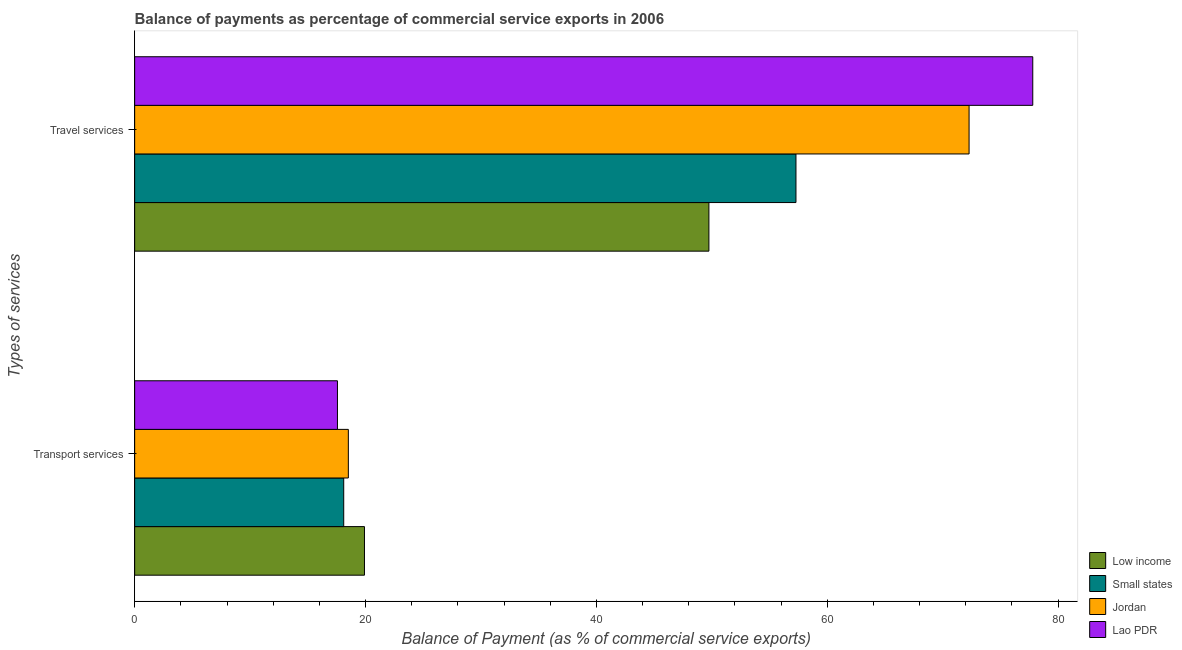How many groups of bars are there?
Give a very brief answer. 2. How many bars are there on the 1st tick from the bottom?
Offer a terse response. 4. What is the label of the 2nd group of bars from the top?
Offer a terse response. Transport services. What is the balance of payments of transport services in Lao PDR?
Keep it short and to the point. 17.57. Across all countries, what is the maximum balance of payments of travel services?
Give a very brief answer. 77.8. Across all countries, what is the minimum balance of payments of transport services?
Offer a very short reply. 17.57. In which country was the balance of payments of travel services maximum?
Ensure brevity in your answer.  Lao PDR. What is the total balance of payments of travel services in the graph?
Your response must be concise. 257.13. What is the difference between the balance of payments of travel services in Low income and that in Jordan?
Make the answer very short. -22.54. What is the difference between the balance of payments of travel services in Low income and the balance of payments of transport services in Lao PDR?
Provide a succinct answer. 32.18. What is the average balance of payments of travel services per country?
Your answer should be compact. 64.28. What is the difference between the balance of payments of travel services and balance of payments of transport services in Lao PDR?
Make the answer very short. 60.24. In how many countries, is the balance of payments of travel services greater than 24 %?
Provide a short and direct response. 4. What is the ratio of the balance of payments of transport services in Small states to that in Lao PDR?
Keep it short and to the point. 1.03. Is the balance of payments of travel services in Small states less than that in Low income?
Give a very brief answer. No. In how many countries, is the balance of payments of transport services greater than the average balance of payments of transport services taken over all countries?
Provide a succinct answer. 1. What does the 1st bar from the top in Travel services represents?
Your answer should be compact. Lao PDR. What does the 3rd bar from the bottom in Transport services represents?
Offer a very short reply. Jordan. How many countries are there in the graph?
Offer a terse response. 4. What is the difference between two consecutive major ticks on the X-axis?
Offer a terse response. 20. Does the graph contain any zero values?
Your answer should be compact. No. How many legend labels are there?
Offer a very short reply. 4. What is the title of the graph?
Make the answer very short. Balance of payments as percentage of commercial service exports in 2006. What is the label or title of the X-axis?
Your response must be concise. Balance of Payment (as % of commercial service exports). What is the label or title of the Y-axis?
Keep it short and to the point. Types of services. What is the Balance of Payment (as % of commercial service exports) in Low income in Transport services?
Provide a succinct answer. 19.91. What is the Balance of Payment (as % of commercial service exports) of Small states in Transport services?
Keep it short and to the point. 18.11. What is the Balance of Payment (as % of commercial service exports) in Jordan in Transport services?
Keep it short and to the point. 18.51. What is the Balance of Payment (as % of commercial service exports) in Lao PDR in Transport services?
Offer a terse response. 17.57. What is the Balance of Payment (as % of commercial service exports) of Low income in Travel services?
Your response must be concise. 49.75. What is the Balance of Payment (as % of commercial service exports) in Small states in Travel services?
Make the answer very short. 57.29. What is the Balance of Payment (as % of commercial service exports) of Jordan in Travel services?
Offer a terse response. 72.29. What is the Balance of Payment (as % of commercial service exports) of Lao PDR in Travel services?
Give a very brief answer. 77.8. Across all Types of services, what is the maximum Balance of Payment (as % of commercial service exports) in Low income?
Provide a succinct answer. 49.75. Across all Types of services, what is the maximum Balance of Payment (as % of commercial service exports) of Small states?
Offer a terse response. 57.29. Across all Types of services, what is the maximum Balance of Payment (as % of commercial service exports) of Jordan?
Provide a succinct answer. 72.29. Across all Types of services, what is the maximum Balance of Payment (as % of commercial service exports) in Lao PDR?
Your answer should be compact. 77.8. Across all Types of services, what is the minimum Balance of Payment (as % of commercial service exports) of Low income?
Offer a terse response. 19.91. Across all Types of services, what is the minimum Balance of Payment (as % of commercial service exports) in Small states?
Make the answer very short. 18.11. Across all Types of services, what is the minimum Balance of Payment (as % of commercial service exports) of Jordan?
Provide a succinct answer. 18.51. Across all Types of services, what is the minimum Balance of Payment (as % of commercial service exports) of Lao PDR?
Provide a short and direct response. 17.57. What is the total Balance of Payment (as % of commercial service exports) in Low income in the graph?
Offer a terse response. 69.66. What is the total Balance of Payment (as % of commercial service exports) of Small states in the graph?
Provide a succinct answer. 75.4. What is the total Balance of Payment (as % of commercial service exports) of Jordan in the graph?
Your answer should be very brief. 90.8. What is the total Balance of Payment (as % of commercial service exports) of Lao PDR in the graph?
Provide a succinct answer. 95.37. What is the difference between the Balance of Payment (as % of commercial service exports) in Low income in Transport services and that in Travel services?
Your answer should be very brief. -29.84. What is the difference between the Balance of Payment (as % of commercial service exports) of Small states in Transport services and that in Travel services?
Provide a succinct answer. -39.18. What is the difference between the Balance of Payment (as % of commercial service exports) of Jordan in Transport services and that in Travel services?
Ensure brevity in your answer.  -53.78. What is the difference between the Balance of Payment (as % of commercial service exports) of Lao PDR in Transport services and that in Travel services?
Your answer should be compact. -60.24. What is the difference between the Balance of Payment (as % of commercial service exports) in Low income in Transport services and the Balance of Payment (as % of commercial service exports) in Small states in Travel services?
Provide a succinct answer. -37.38. What is the difference between the Balance of Payment (as % of commercial service exports) of Low income in Transport services and the Balance of Payment (as % of commercial service exports) of Jordan in Travel services?
Your answer should be very brief. -52.38. What is the difference between the Balance of Payment (as % of commercial service exports) of Low income in Transport services and the Balance of Payment (as % of commercial service exports) of Lao PDR in Travel services?
Offer a terse response. -57.9. What is the difference between the Balance of Payment (as % of commercial service exports) of Small states in Transport services and the Balance of Payment (as % of commercial service exports) of Jordan in Travel services?
Give a very brief answer. -54.18. What is the difference between the Balance of Payment (as % of commercial service exports) of Small states in Transport services and the Balance of Payment (as % of commercial service exports) of Lao PDR in Travel services?
Offer a terse response. -59.69. What is the difference between the Balance of Payment (as % of commercial service exports) in Jordan in Transport services and the Balance of Payment (as % of commercial service exports) in Lao PDR in Travel services?
Offer a very short reply. -59.29. What is the average Balance of Payment (as % of commercial service exports) of Low income per Types of services?
Keep it short and to the point. 34.83. What is the average Balance of Payment (as % of commercial service exports) of Small states per Types of services?
Give a very brief answer. 37.7. What is the average Balance of Payment (as % of commercial service exports) in Jordan per Types of services?
Keep it short and to the point. 45.4. What is the average Balance of Payment (as % of commercial service exports) in Lao PDR per Types of services?
Give a very brief answer. 47.69. What is the difference between the Balance of Payment (as % of commercial service exports) in Low income and Balance of Payment (as % of commercial service exports) in Small states in Transport services?
Your answer should be compact. 1.8. What is the difference between the Balance of Payment (as % of commercial service exports) of Low income and Balance of Payment (as % of commercial service exports) of Jordan in Transport services?
Provide a short and direct response. 1.4. What is the difference between the Balance of Payment (as % of commercial service exports) in Low income and Balance of Payment (as % of commercial service exports) in Lao PDR in Transport services?
Your answer should be compact. 2.34. What is the difference between the Balance of Payment (as % of commercial service exports) in Small states and Balance of Payment (as % of commercial service exports) in Jordan in Transport services?
Your response must be concise. -0.4. What is the difference between the Balance of Payment (as % of commercial service exports) of Small states and Balance of Payment (as % of commercial service exports) of Lao PDR in Transport services?
Your response must be concise. 0.54. What is the difference between the Balance of Payment (as % of commercial service exports) of Jordan and Balance of Payment (as % of commercial service exports) of Lao PDR in Transport services?
Your answer should be compact. 0.94. What is the difference between the Balance of Payment (as % of commercial service exports) of Low income and Balance of Payment (as % of commercial service exports) of Small states in Travel services?
Ensure brevity in your answer.  -7.54. What is the difference between the Balance of Payment (as % of commercial service exports) of Low income and Balance of Payment (as % of commercial service exports) of Jordan in Travel services?
Your answer should be very brief. -22.54. What is the difference between the Balance of Payment (as % of commercial service exports) in Low income and Balance of Payment (as % of commercial service exports) in Lao PDR in Travel services?
Ensure brevity in your answer.  -28.06. What is the difference between the Balance of Payment (as % of commercial service exports) of Small states and Balance of Payment (as % of commercial service exports) of Jordan in Travel services?
Your response must be concise. -15. What is the difference between the Balance of Payment (as % of commercial service exports) of Small states and Balance of Payment (as % of commercial service exports) of Lao PDR in Travel services?
Keep it short and to the point. -20.51. What is the difference between the Balance of Payment (as % of commercial service exports) in Jordan and Balance of Payment (as % of commercial service exports) in Lao PDR in Travel services?
Provide a succinct answer. -5.52. What is the ratio of the Balance of Payment (as % of commercial service exports) in Low income in Transport services to that in Travel services?
Provide a short and direct response. 0.4. What is the ratio of the Balance of Payment (as % of commercial service exports) of Small states in Transport services to that in Travel services?
Give a very brief answer. 0.32. What is the ratio of the Balance of Payment (as % of commercial service exports) in Jordan in Transport services to that in Travel services?
Your answer should be compact. 0.26. What is the ratio of the Balance of Payment (as % of commercial service exports) in Lao PDR in Transport services to that in Travel services?
Provide a succinct answer. 0.23. What is the difference between the highest and the second highest Balance of Payment (as % of commercial service exports) of Low income?
Your response must be concise. 29.84. What is the difference between the highest and the second highest Balance of Payment (as % of commercial service exports) of Small states?
Provide a short and direct response. 39.18. What is the difference between the highest and the second highest Balance of Payment (as % of commercial service exports) in Jordan?
Make the answer very short. 53.78. What is the difference between the highest and the second highest Balance of Payment (as % of commercial service exports) of Lao PDR?
Give a very brief answer. 60.24. What is the difference between the highest and the lowest Balance of Payment (as % of commercial service exports) in Low income?
Your answer should be very brief. 29.84. What is the difference between the highest and the lowest Balance of Payment (as % of commercial service exports) of Small states?
Give a very brief answer. 39.18. What is the difference between the highest and the lowest Balance of Payment (as % of commercial service exports) of Jordan?
Offer a terse response. 53.78. What is the difference between the highest and the lowest Balance of Payment (as % of commercial service exports) in Lao PDR?
Your answer should be compact. 60.24. 